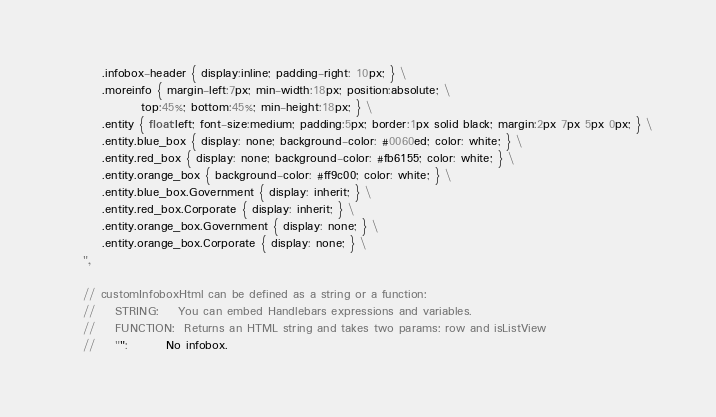Convert code to text. <code><loc_0><loc_0><loc_500><loc_500><_JavaScript_>        .infobox-header { display:inline; padding-right: 10px; } \
        .moreinfo { margin-left:7px; min-width:18px; position:absolute; \
                top:45%; bottom:45%; min-height:18px; } \
        .entity { float:left; font-size:medium; padding:5px; border:1px solid black; margin:2px 7px 5px 0px; } \
        .entity.blue_box { display: none; background-color: #0060ed; color: white; } \
        .entity.red_box { display: none; background-color: #fb6155; color: white; } \
        .entity.orange_box { background-color: #ff9c00; color: white; } \
        .entity.blue_box.Government { display: inherit; } \
        .entity.red_box.Corporate { display: inherit; } \
        .entity.orange_box.Government { display: none; } \
        .entity.orange_box.Corporate { display: none; } \
    ",

    // customInfoboxHtml can be defined as a string or a function:
    //    STRING:    You can embed Handlebars expressions and variables.
    //    FUNCTION:  Returns an HTML string and takes two params: row and isListView
    //    "":        No infobox.</code> 